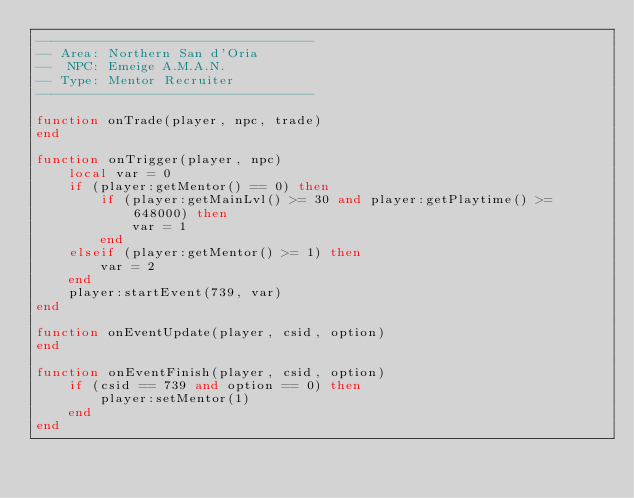<code> <loc_0><loc_0><loc_500><loc_500><_Lua_>-----------------------------------
-- Area: Northern San d'Oria
--  NPC: Emeige A.M.A.N.
-- Type: Mentor Recruiter
-----------------------------------

function onTrade(player, npc, trade)
end

function onTrigger(player, npc)
    local var = 0
    if (player:getMentor() == 0) then
        if (player:getMainLvl() >= 30 and player:getPlaytime() >= 648000) then
            var = 1
        end
    elseif (player:getMentor() >= 1) then
        var = 2
    end
    player:startEvent(739, var)
end

function onEventUpdate(player, csid, option)
end

function onEventFinish(player, csid, option)
    if (csid == 739 and option == 0) then
        player:setMentor(1)
    end
end
</code> 